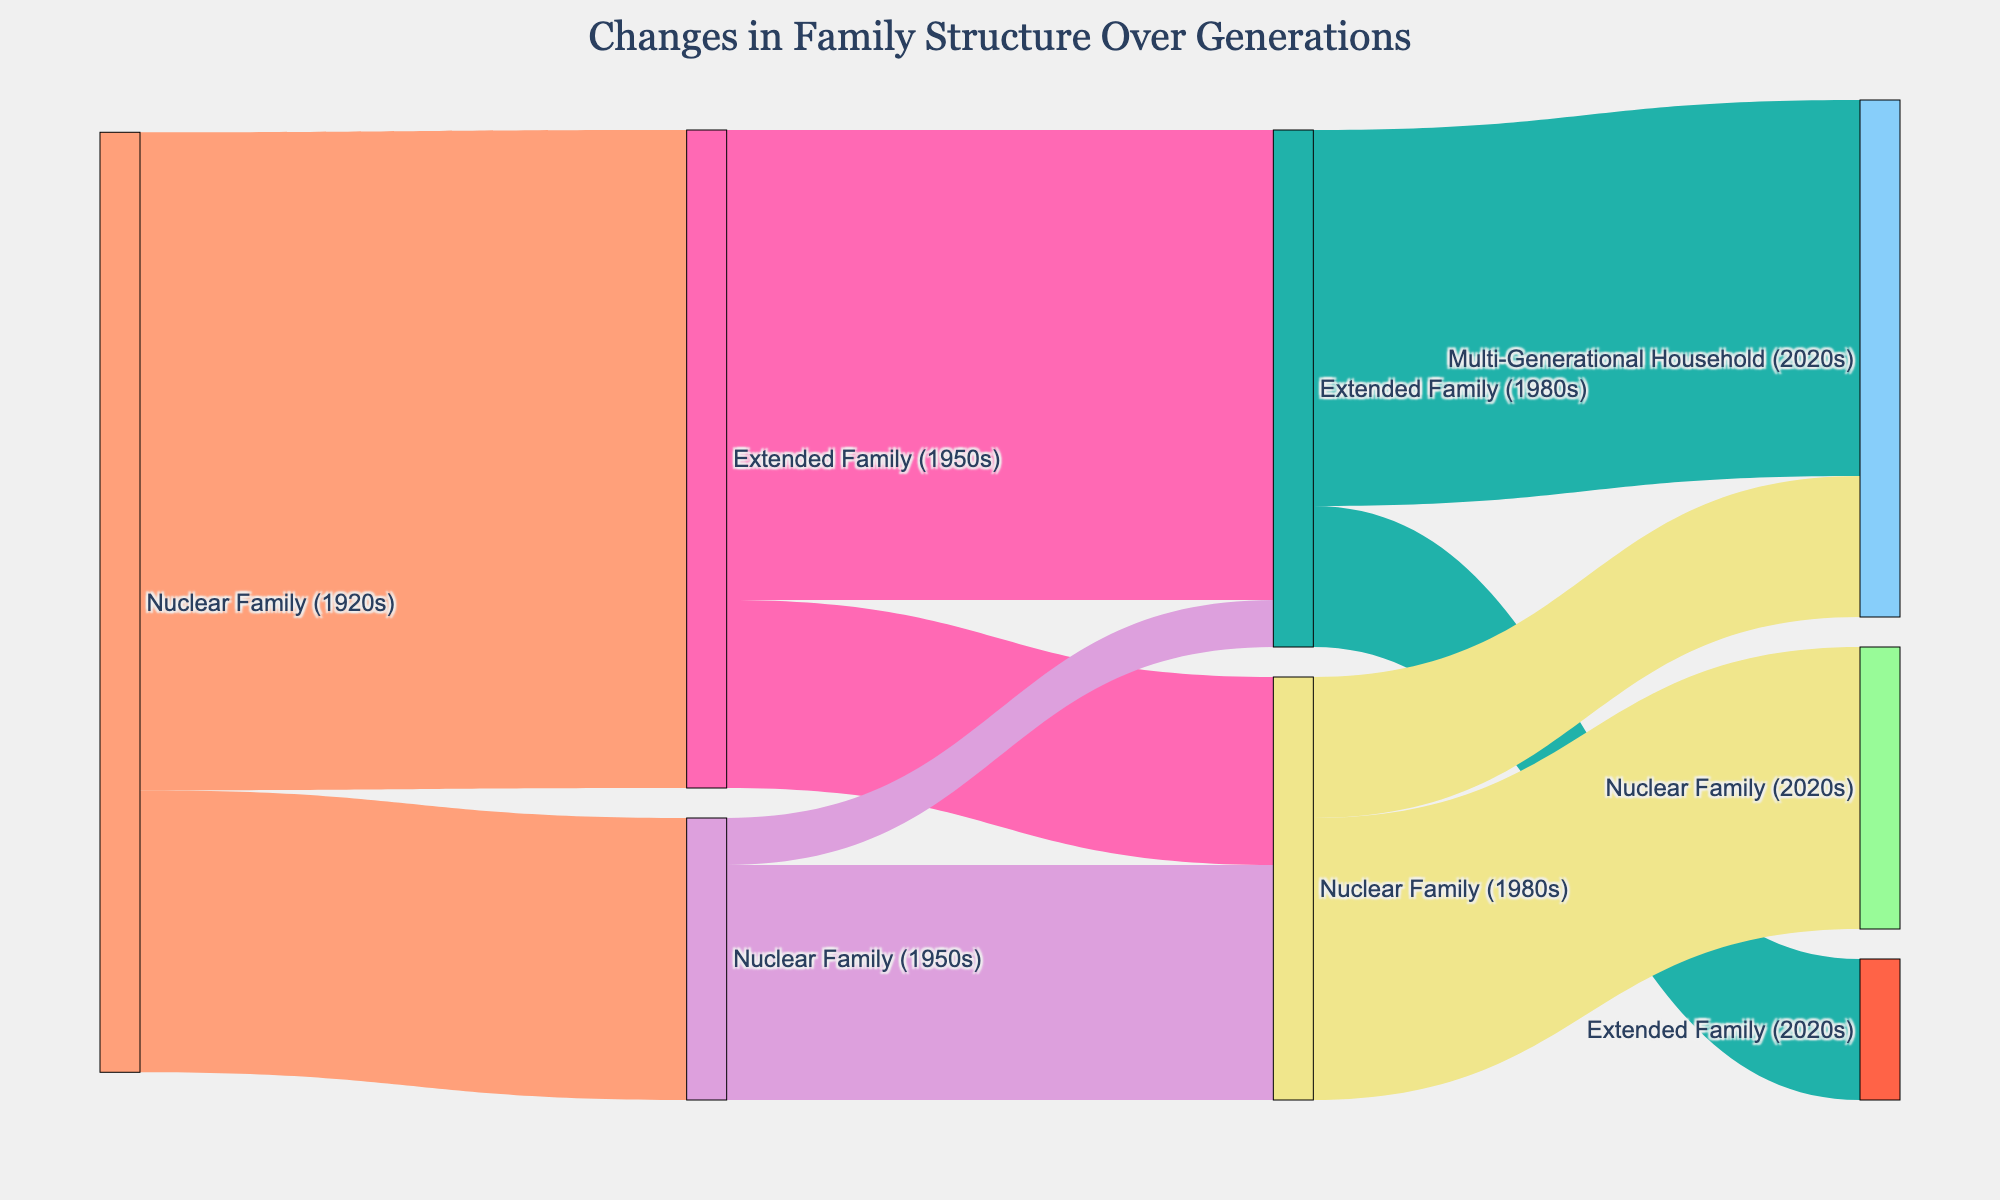What is the title of the Sankey diagram? The title of the Sankey diagram is usually displayed at the top of the figure. In this case, it is provided in the description of the layout under the title_text parameter.
Answer: Changes in Family Structure Over Generations How many different family structures are represented in the diagram? The labels section lists all the unique family structures displayed in the diagram. Counting these labels gives us the total number of different family structures.
Answer: 6 What is the most common transition from a nuclear family in the 1920s? By examining the values associated with the transitions from the Nuclear Family (1920s) to the other family structures in the 1950s, we can see that the transition with the highest value indicates the most common transition.
Answer: Extended Family (1950s) How many transitions involve a nuclear family in the 1950s? We need to count the number of links that have Nuclear Family (1950s) as either the source or the target node.
Answer: 3 What percentage of families were part of an extended family in the 1980s? To find this, we need to examine the values of links pointing to Extended Family (1980s) and sum them up, then divide by the total number of families in the 1980s.
Answer: 55% Does the diagram show more transitions to extended families or nuclear families in the 2020s? We compare the number of and the values of the transitions that end at Extended Family (2020s) with those that end at Nuclear Family (2020s).
Answer: Nuclear families How many families transitioned from a nuclear family in the 1980s to a multi-generational household in the 2020s? By looking at the value associated with the transition from Nuclear Family (1980s) to Multi-Generational Household (2020s), we can determine the number of families involved.
Answer: 15 What is the largest single transition in the entire diagram? Finding the link with the highest value will give us the largest single transition in the diagram.
Answer: Nuclear Family (1920s) to Extended Family (1950s) How many families were part of a nuclear family in all three periods: 1920s, 1950s, and 1980s? We need to look for a continuous transition from Nuclear Family (1920s) to Nuclear Family (1950s) and then to Nuclear Family (1980s) and sum the values associated with these transitions.
Answer: 25 